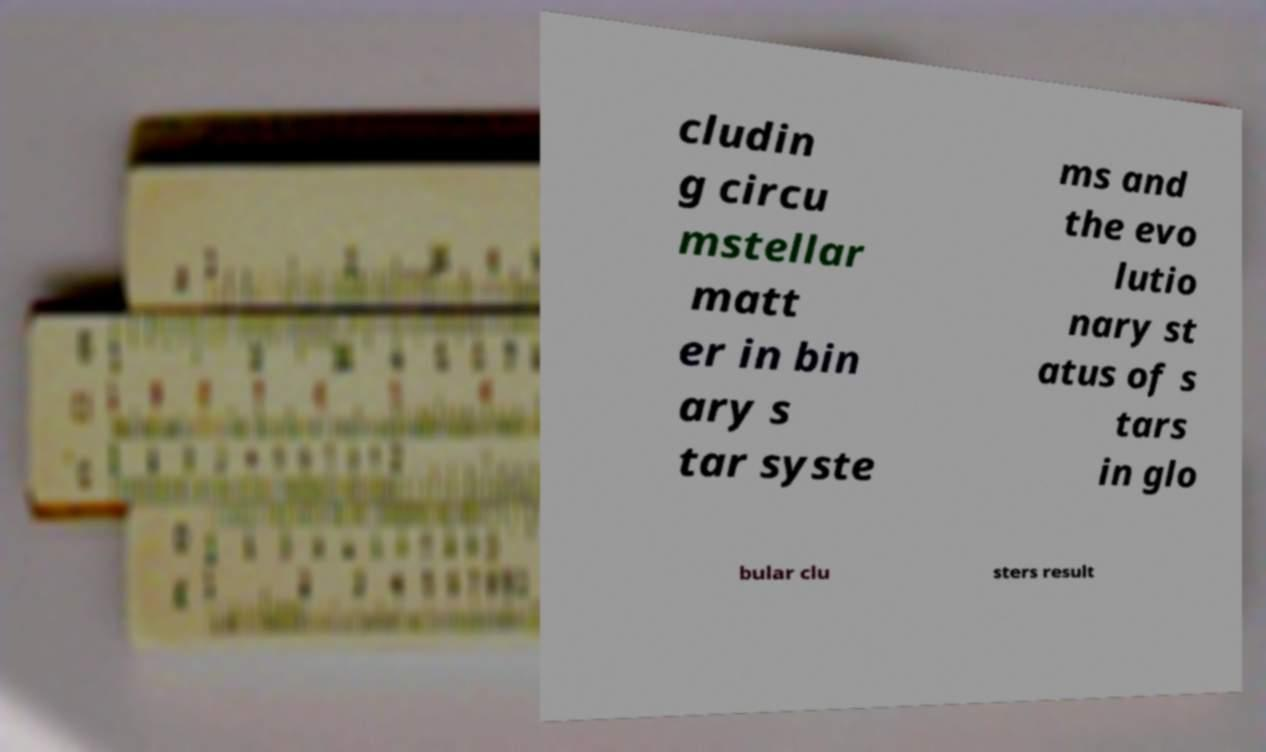Could you extract and type out the text from this image? cludin g circu mstellar matt er in bin ary s tar syste ms and the evo lutio nary st atus of s tars in glo bular clu sters result 